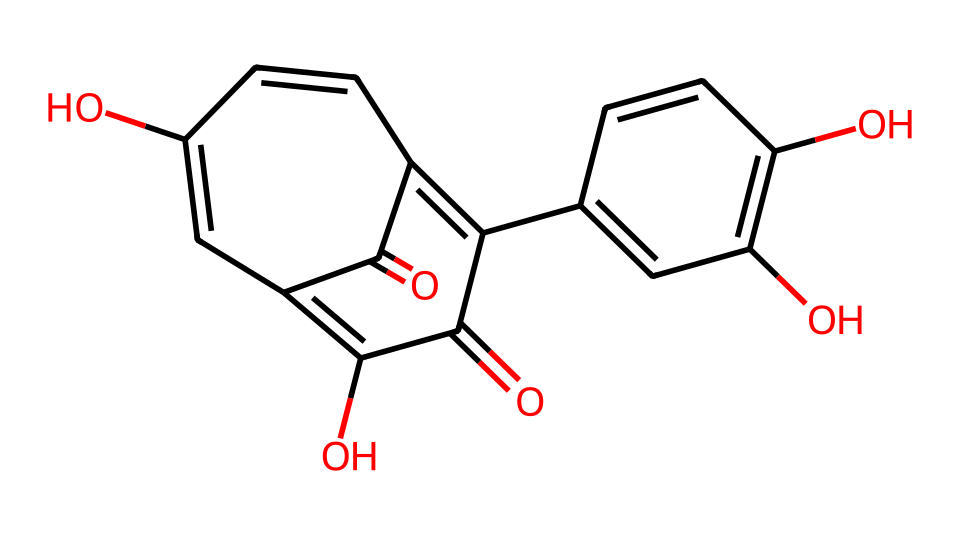How many rings are present in quercetin? The SMILES representation shows that there are several interconnected carbocyclic structures. By analyzing the structure and counting the fused rings, we can determine that there are three distinct rings.
Answer: three What is the primary functional group present in quercetin? Analyzing the structure, we see multiple hydroxyl (–OH) groups present in the chemical. These functional groups are indicative of phenolic compounds and are the primary functional groups in quercetin.
Answer: hydroxyl How many carbon atoms are in quercetin? By examining the SMILES, we can count the number of carbon atoms represented in the structure. A thorough count reveals that there are 15 carbon atoms in total.
Answer: fifteen What type of agent is quercetin classified as? Given its antioxidant properties and its presence in foods such as Swiss chocolate, quercetin is classified as an antioxidant agent.
Answer: antioxidant Which part of the structure suggests quercetin's antioxidant properties? The presence of multiple hydroxyl groups in the structure contributes to its ability to donate electrons and neutralize free radicals, suggesting its antioxidant properties.
Answer: hydroxyl groups How many double bonds can be identified in quercetin? Upon analyzing the structure, we can count the number of double bonds within the fused rings and aromatic segments of the molecule. A detailed review shows that there are six double bonds.
Answer: six What type of natural products is quercetin categorized under? Quercetin is recognized as a flavonoid, which is a subclass of polyphenols widely found in plants. This categorization stems from its structural characteristics and its occurrence in various fruits and vegetables.
Answer: flavonoid 